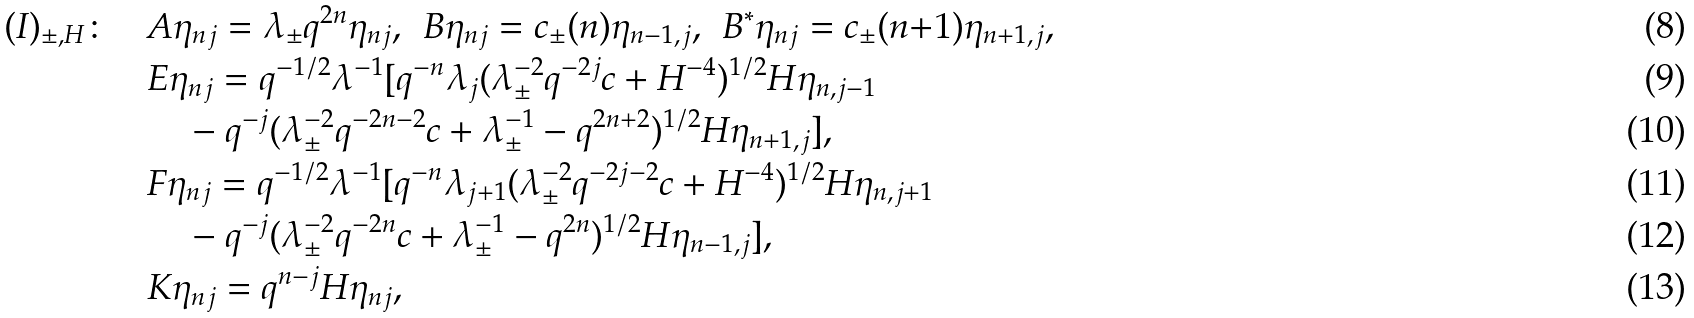Convert formula to latex. <formula><loc_0><loc_0><loc_500><loc_500>( I ) _ { \pm , H } \colon \quad & A \eta _ { n j } = \lambda _ { \pm } q ^ { 2 n } \eta _ { n j } , \ \, B \eta _ { n j } = c _ { \pm } ( n ) \eta _ { n - 1 , j } , \ \, B ^ { \ast } \eta _ { n j } = c _ { \pm } ( n { + } 1 ) \eta _ { n + 1 , j } , \\ & E \eta _ { n j } = q ^ { - 1 / 2 } \lambda ^ { - 1 } [ q ^ { - n } \lambda _ { j } ( \lambda _ { \pm } ^ { - 2 } q ^ { - 2 j } c + H ^ { - 4 } ) ^ { 1 / 2 } H \eta _ { n , j - 1 } \\ & \quad - q ^ { - j } ( \lambda ^ { - 2 } _ { \pm } q ^ { - 2 n - 2 } c + \lambda ^ { - 1 } _ { \pm } - q ^ { 2 n + 2 } ) ^ { 1 / 2 } H \eta _ { n + 1 , j } ] , \\ & F \eta _ { n j } = q ^ { - 1 / 2 } \lambda ^ { - 1 } [ q ^ { - n } \lambda _ { j + 1 } ( \lambda ^ { - 2 } _ { \pm } q ^ { - 2 j - 2 } c + H ^ { - 4 } ) ^ { 1 / 2 } H \eta _ { n , j + 1 } \\ & \quad - q ^ { - j } ( \lambda ^ { - 2 } _ { \pm } q ^ { - 2 n } c + \lambda ^ { - 1 } _ { \pm } - q ^ { 2 n } ) ^ { 1 / 2 } H \eta _ { n - 1 , j } ] , \\ & K \eta _ { n j } = q ^ { n - j } H \eta _ { n j } ,</formula> 